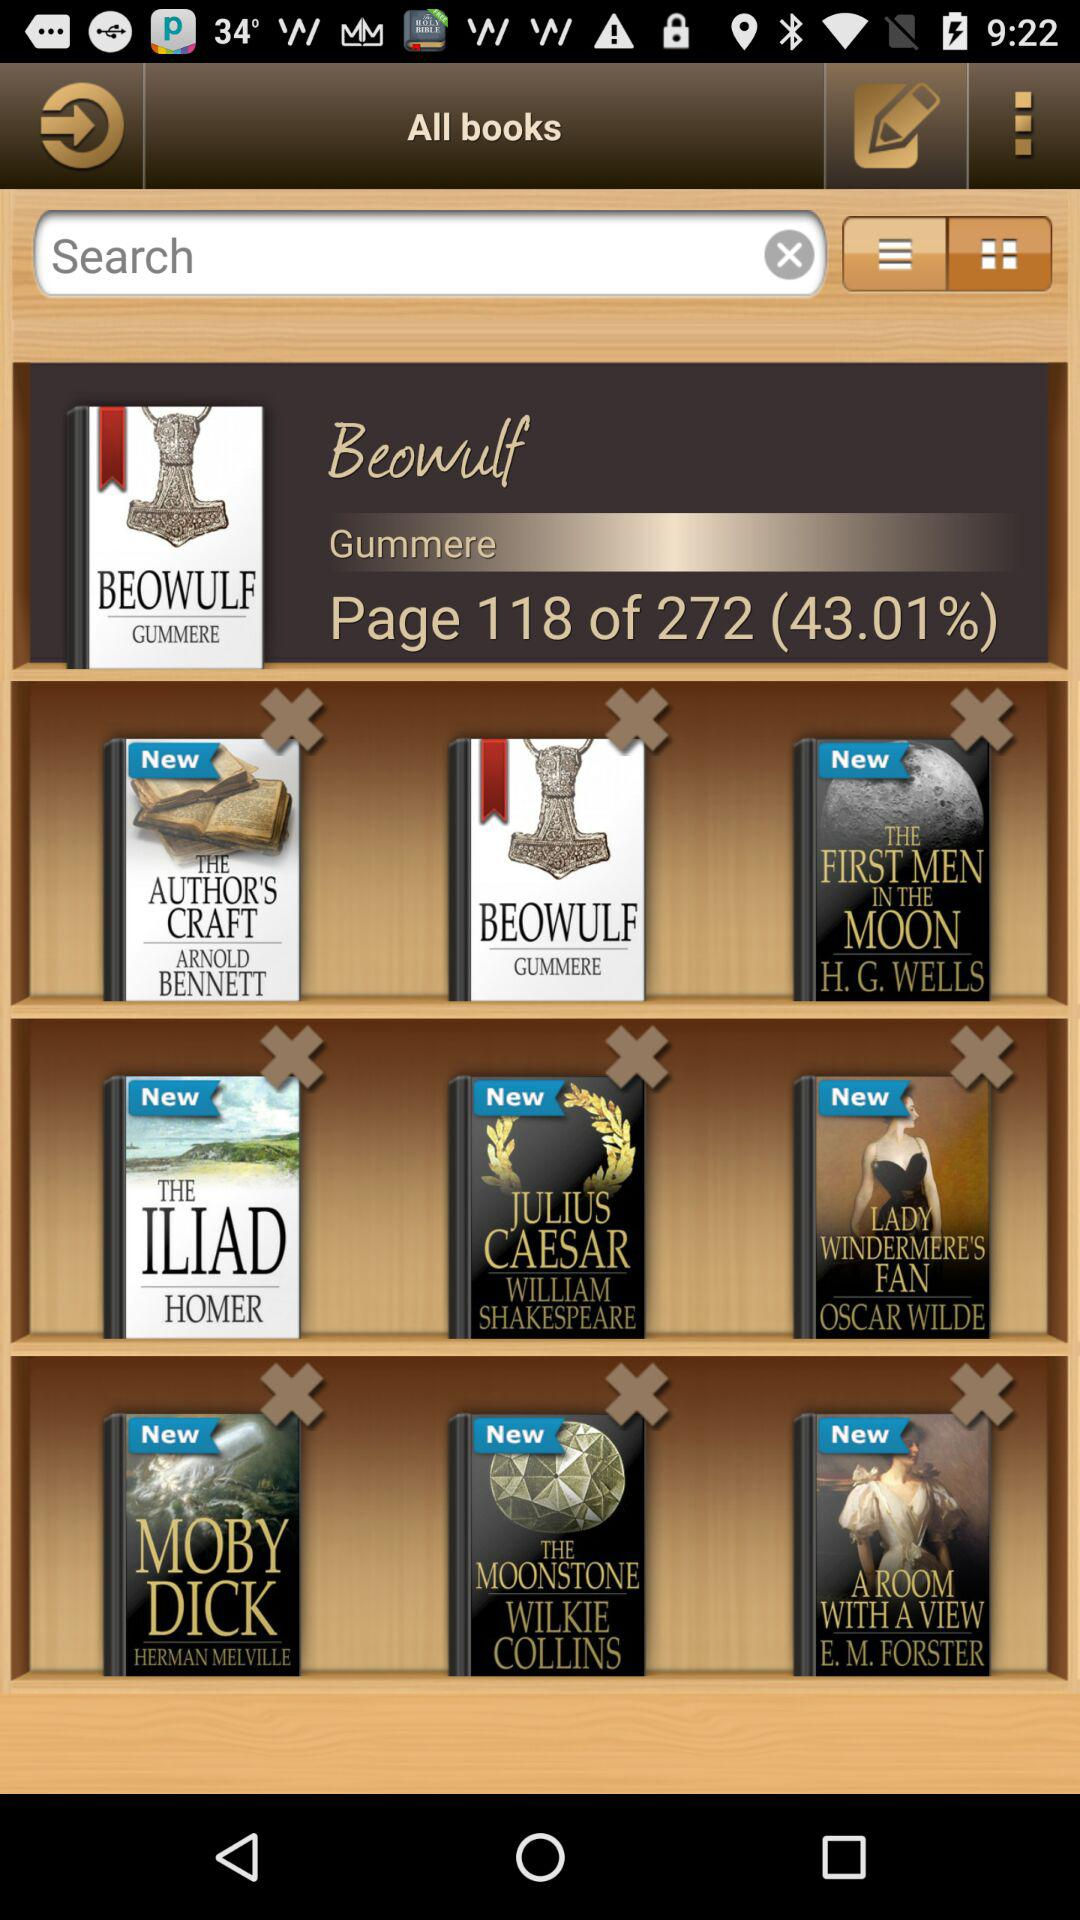How much percentage of the "Beowulf" book has been downloaded? The percentage of the "Beowulf" book that has been downloaded is 43.01%. 